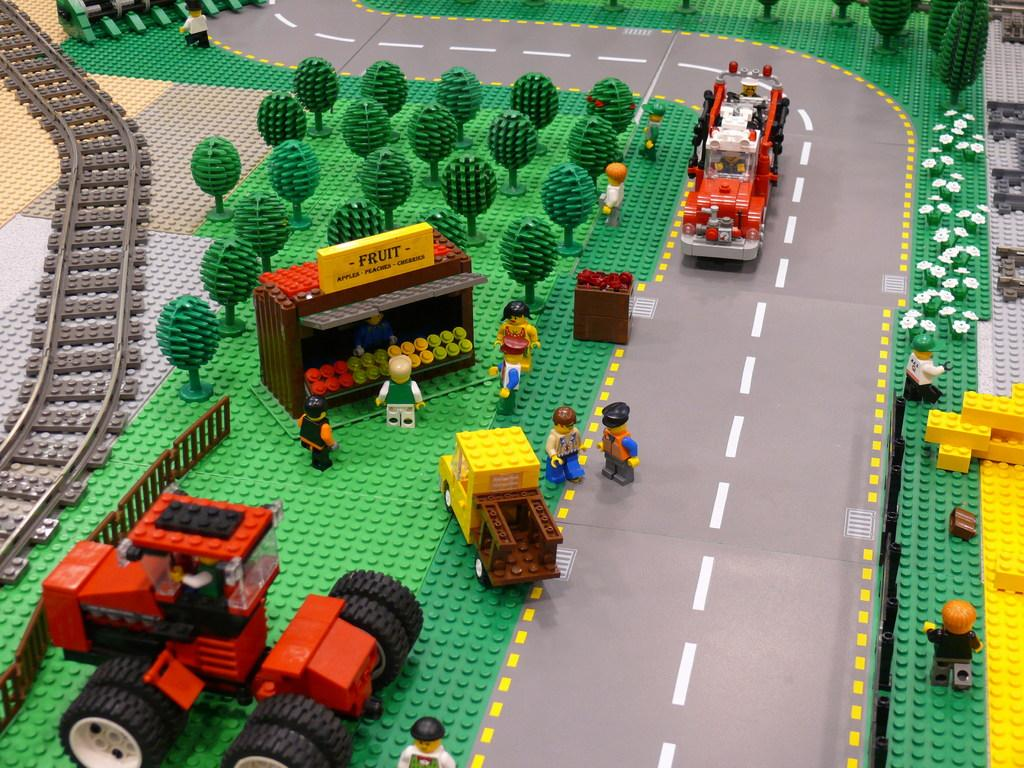<image>
Create a compact narrative representing the image presented. Lego stand which says the word FRUIT on it. 